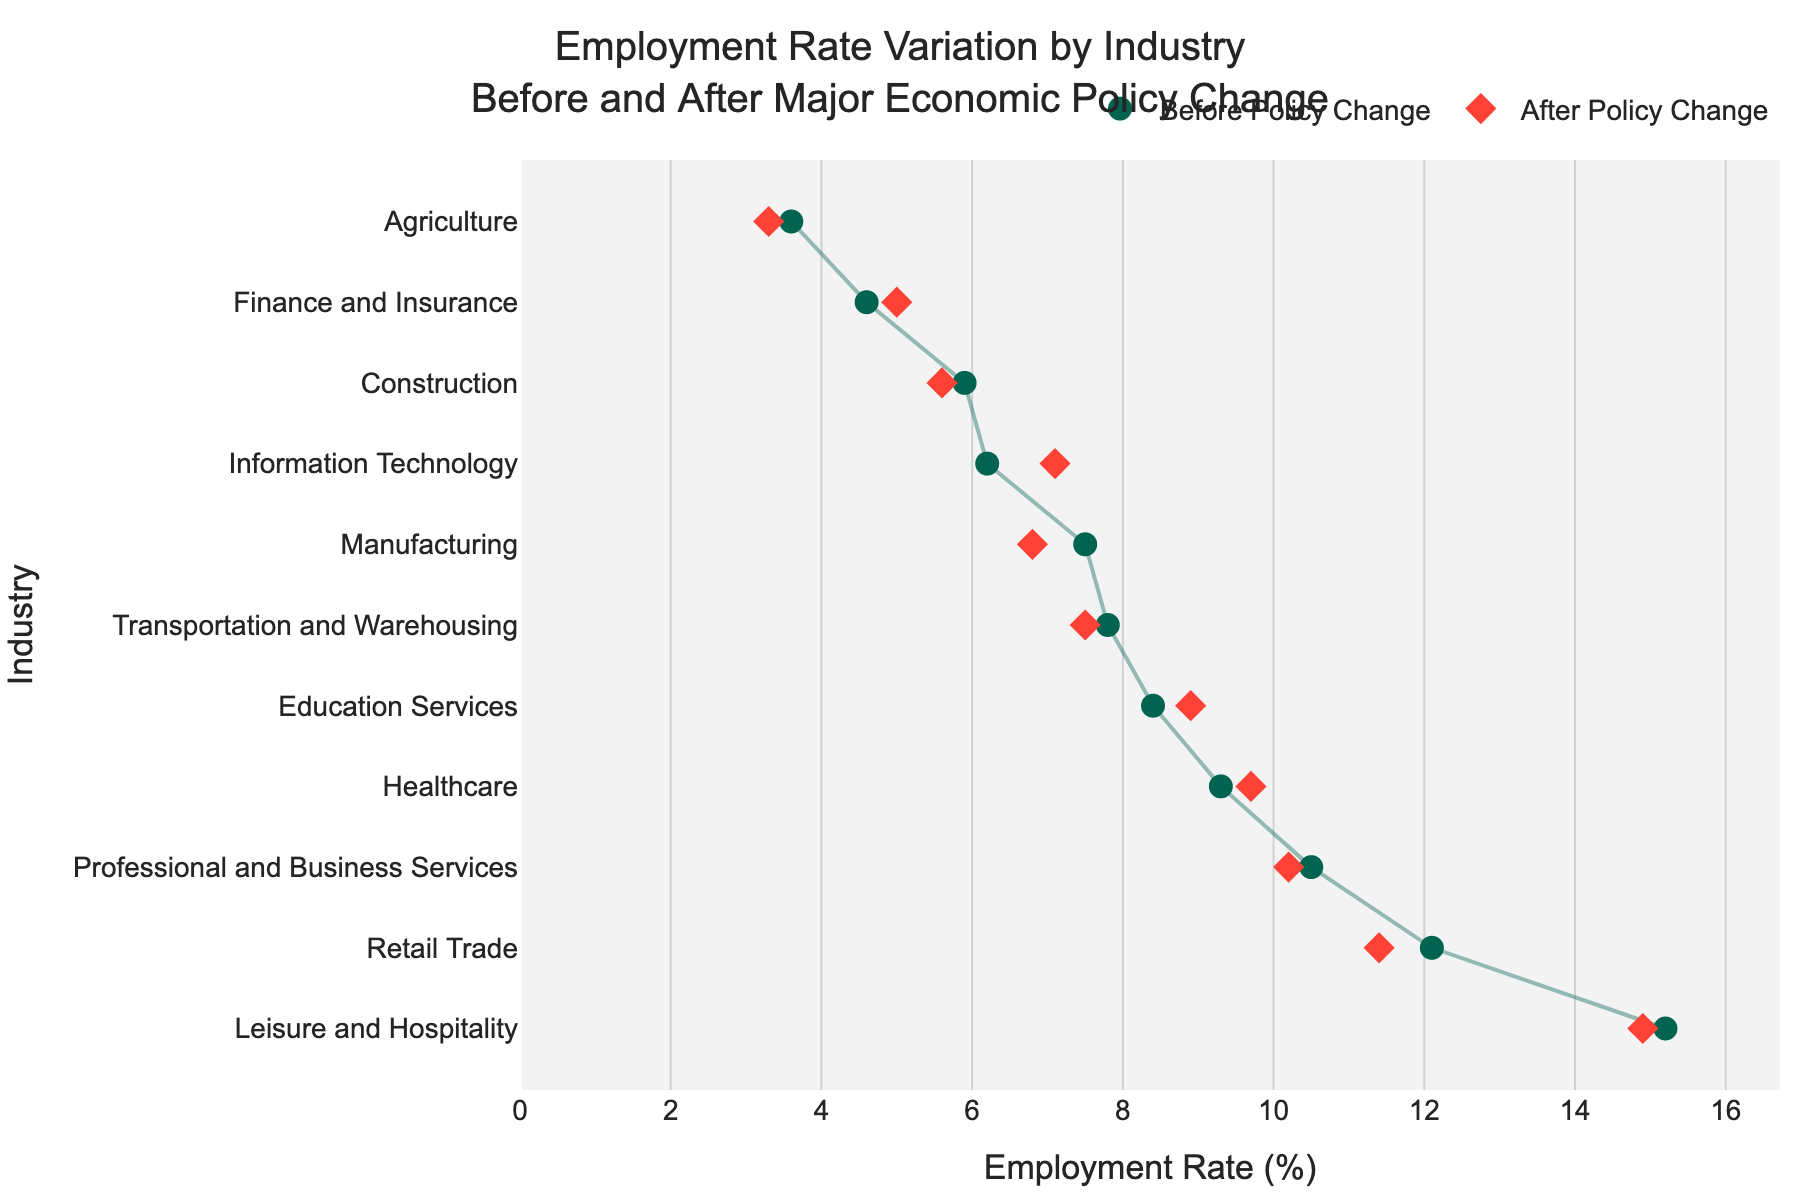What's the title of the plot? The title of the plot is usually displayed at the top of the figure. It provides an overview of what the plot represents.
Answer: Employment Rate Variation by Industry Before and After Major Economic Policy Change How many industries are represented in the plot? The y-axis of the plot lists all the industries represented. Counting these industries gives the total number.
Answer: 11 What is the employment rate for Manufacturing before the policy change? Look for the circle marker corresponding to the industry "Manufacturing" on the y-axis and check its position on the x-axis, which represents the rate before the policy change.
Answer: 7.5% Which industry experienced the highest employment rate increase after the policy change? Compare the position of the diamond markers (after policy change) relative to the circle markers (before policy change) for each industry to find the largest increase.
Answer: Information Technology What's the average employment rate after the policy change for all industries listed? Calculate the average by summing up the employment rates after the policy change for all the industries and dividing by the number of industries. Sum = 6.8 + 5.6 + 9.7 + 7.1 + 11.4 + 5.0 + 8.9 + 10.2 + 14.9 + 7.5 + 3.3 = 90.4. Average = 90.4 / 11.
Answer: 8.22% Which industry had the largest decrease in employment rate after the policy change? Identify the industry with the biggest difference between the circle marker (before policy change) and the diamond marker (after policy change) on the x-axis.
Answer: Retail Trade Which two industries have the smallest difference in employment rates before and after the policy change? Compare the differences for all industries and find the two smallest.
Answer: Construction and Transportation and Warehousing Did the employment rate for Healthcare increase or decrease after the policy change? Compare the position of the diamond marker (after) to the circle marker (before) for Healthcare to determine if it increased or decreased.
Answer: Increased In which industry is the employment rate after the policy change the highest? Look for the diamond marker (after policy) that is furthest to the right on the x-axis.
Answer: Leisure and Hospitality What is the employment rate difference before and after the policy change for Professional and Business Services? Subtract the employment rate after the policy change from the rate before the policy change for Professional and Business Services. Difference = 10.5 - 10.2.
Answer: 0.3% 